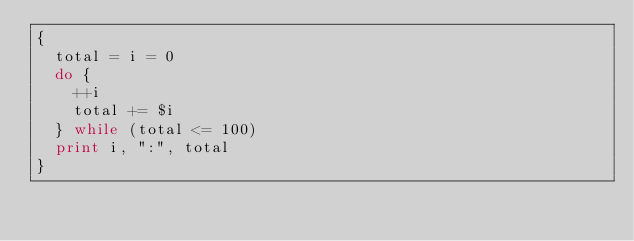Convert code to text. <code><loc_0><loc_0><loc_500><loc_500><_Awk_>{
  total = i = 0
  do {
    ++i
    total += $i
  } while (total <= 100)
  print i, ":", total
}
</code> 